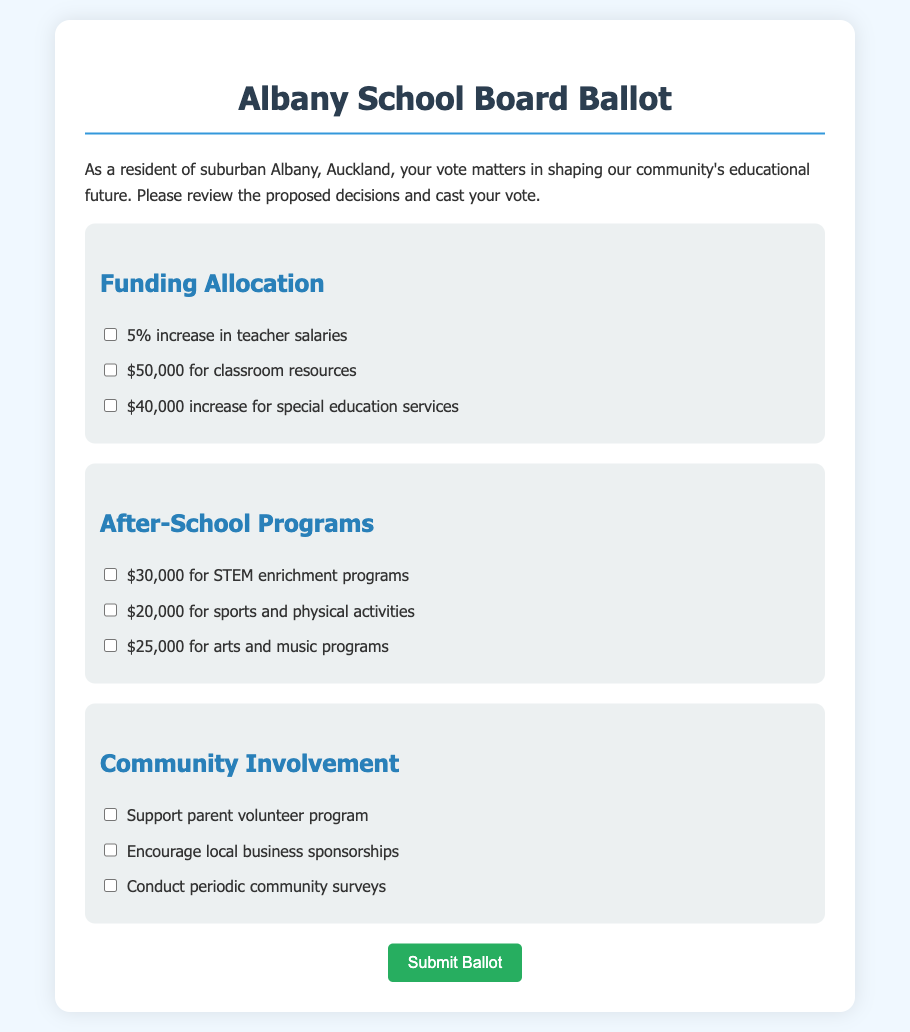what is the proposed percentage increase in teacher salaries? The proposed percentage increase in teacher salaries is stated in the "Funding Allocation" section of the document as 5%.
Answer: 5% how much is allocated for classroom resources? The allocation for classroom resources is specified in the "Funding Allocation" section as $50,000.
Answer: $50,000 what is the total funding increase for special education services? The total funding increase for special education services is mentioned as $40,000 in the "Funding Allocation" section.
Answer: $40,000 how much funding is proposed for STEM enrichment programs? The proposed funding for STEM enrichment programs is listed in the "After-School Programs" section as $30,000.
Answer: $30,000 what kind of program supports local business sponsorships? The option to encourage local business sponsorships is detailed under "Community Involvement."
Answer: Encourage local business sponsorships what is the total amount proposed for sports and physical activities? The total amount proposed for sports and physical activities is mentioned in the "After-School Programs" section as $20,000.
Answer: $20,000 which section includes conducting periodic community surveys? Conducting periodic community surveys is included in the "Community Involvement" section.
Answer: Community Involvement how many options are there for funding allocation? There are three options provided in the "Funding Allocation" section of the document.
Answer: Three what is the background color of the ballot? The background color of the ballot, as described in the document, is a light blue (#f0f8ff).
Answer: Light blue what element serves as the title of the document? The title of the document is represented by a header, specifically the text "Albany School Board Ballot."
Answer: Albany School Board Ballot 